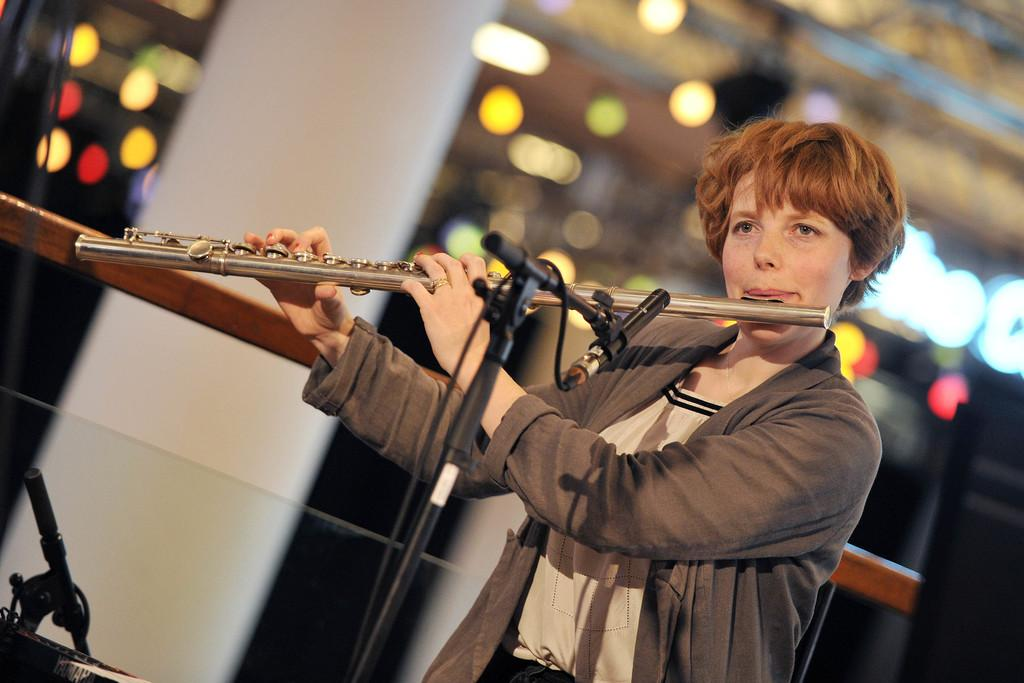What is the person in the image doing? The person is playing a flute. What object is present in the image that might be used for amplifying sound? There is a microphone in the image. Can you describe the background of the image? The background of the image is blurry. What type of farm animals can be seen in the image? There are no farm animals present in the image. How does the guide assist the person playing the flute in the image? There is no guide present in the image. What type of snack is being served in the image? There is no snack, such as popcorn, present in the image. 